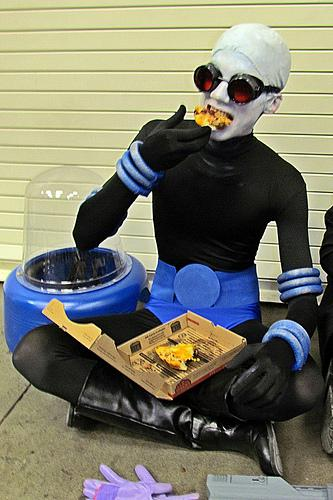Question: what color belt is the person wearing?
Choices:
A. Black.
B. Blue.
C. Brown.
D. White.
Answer with the letter. Answer: B Question: how many purple gloves?
Choices:
A. One.
B. Three.
C. Four.
D. Two.
Answer with the letter. Answer: D Question: where are the purple gloves?
Choices:
A. Floor.
B. Bed.
C. Counter.
D. In the tree.
Answer with the letter. Answer: A Question: what is on the person's eyes?
Choices:
A. Goggles.
B. Glasses.
C. Sunshades.
D. Makeup.
Answer with the letter. Answer: A Question: who has a painted white face?
Choices:
A. A child.
B. The person does.
C. A mom.
D. A clown.
Answer with the letter. Answer: B 